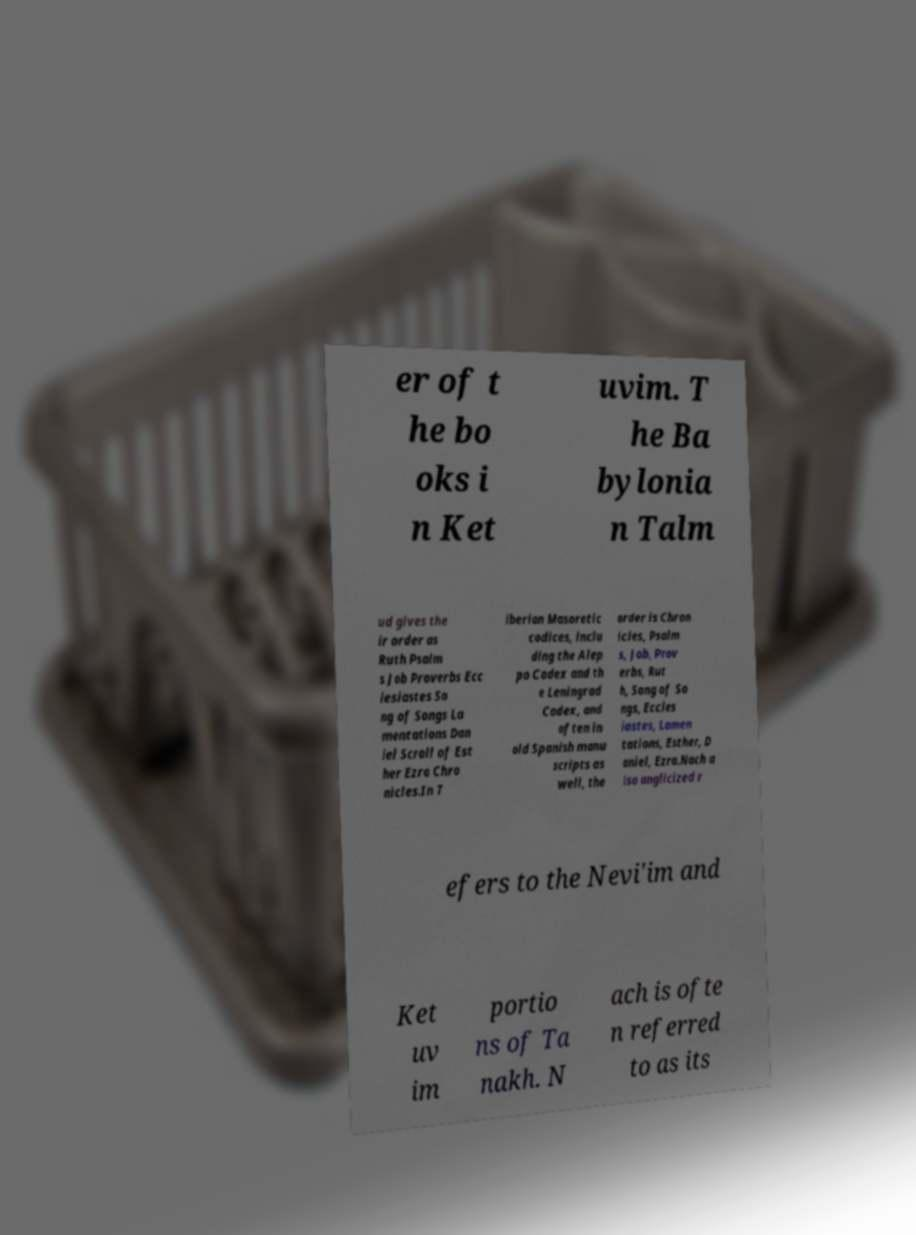Could you extract and type out the text from this image? er of t he bo oks i n Ket uvim. T he Ba bylonia n Talm ud gives the ir order as Ruth Psalm s Job Proverbs Ecc lesiastes So ng of Songs La mentations Dan iel Scroll of Est her Ezra Chro nicles.In T iberian Masoretic codices, inclu ding the Alep po Codex and th e Leningrad Codex, and often in old Spanish manu scripts as well, the order is Chron icles, Psalm s, Job, Prov erbs, Rut h, Song of So ngs, Eccles iastes, Lamen tations, Esther, D aniel, Ezra.Nach a lso anglicized r efers to the Nevi'im and Ket uv im portio ns of Ta nakh. N ach is ofte n referred to as its 